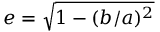Convert formula to latex. <formula><loc_0><loc_0><loc_500><loc_500>e = { \sqrt { 1 - ( b / a ) ^ { 2 } } }</formula> 